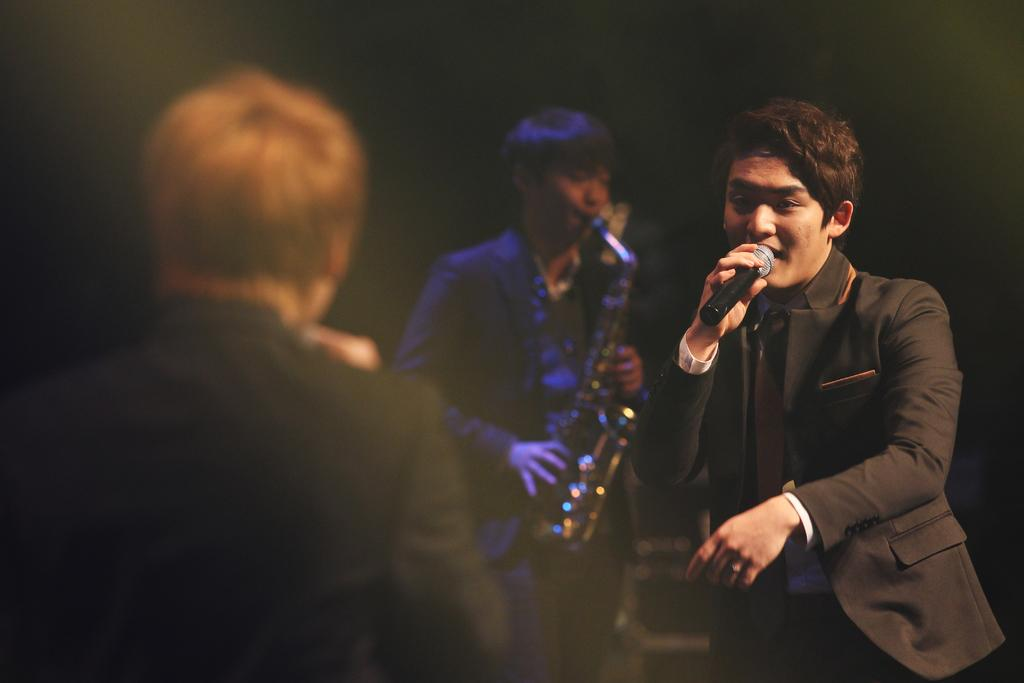How many people are in the image? There are three persons in the image. What are the people doing in the image? One person is holding a musical instrument, and another person is holding a microphone and singing. Can you describe the third person be seen doing something specific? The third person's actions are not mentioned in the provided facts, so we cannot definitively answer this question. What type of support can be seen in the image for the market? There is no mention of a market or any type of support in the image. 